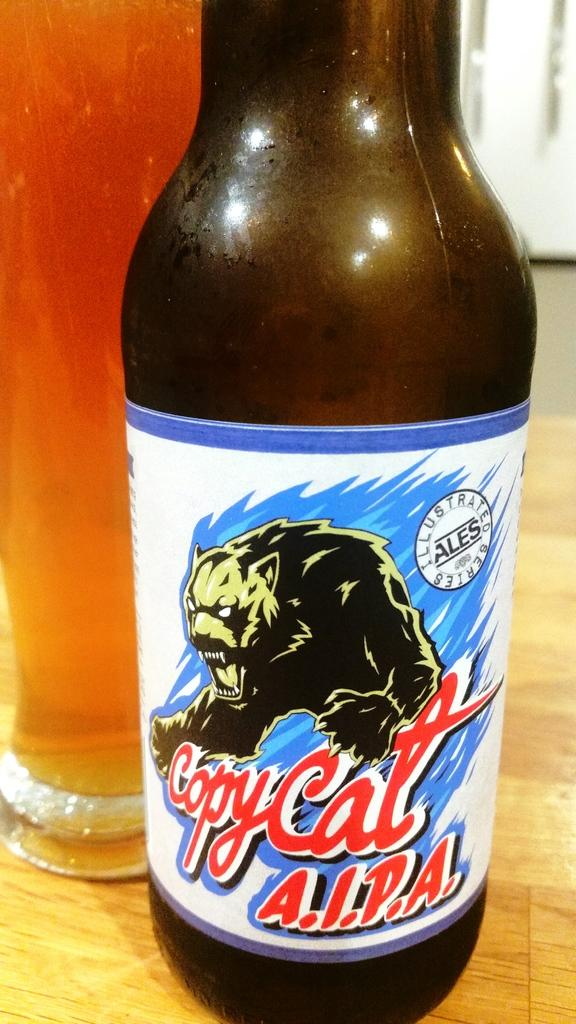<image>
Give a short and clear explanation of the subsequent image. A close up shot of a beer bottle from the company Copy Cat AIPA 